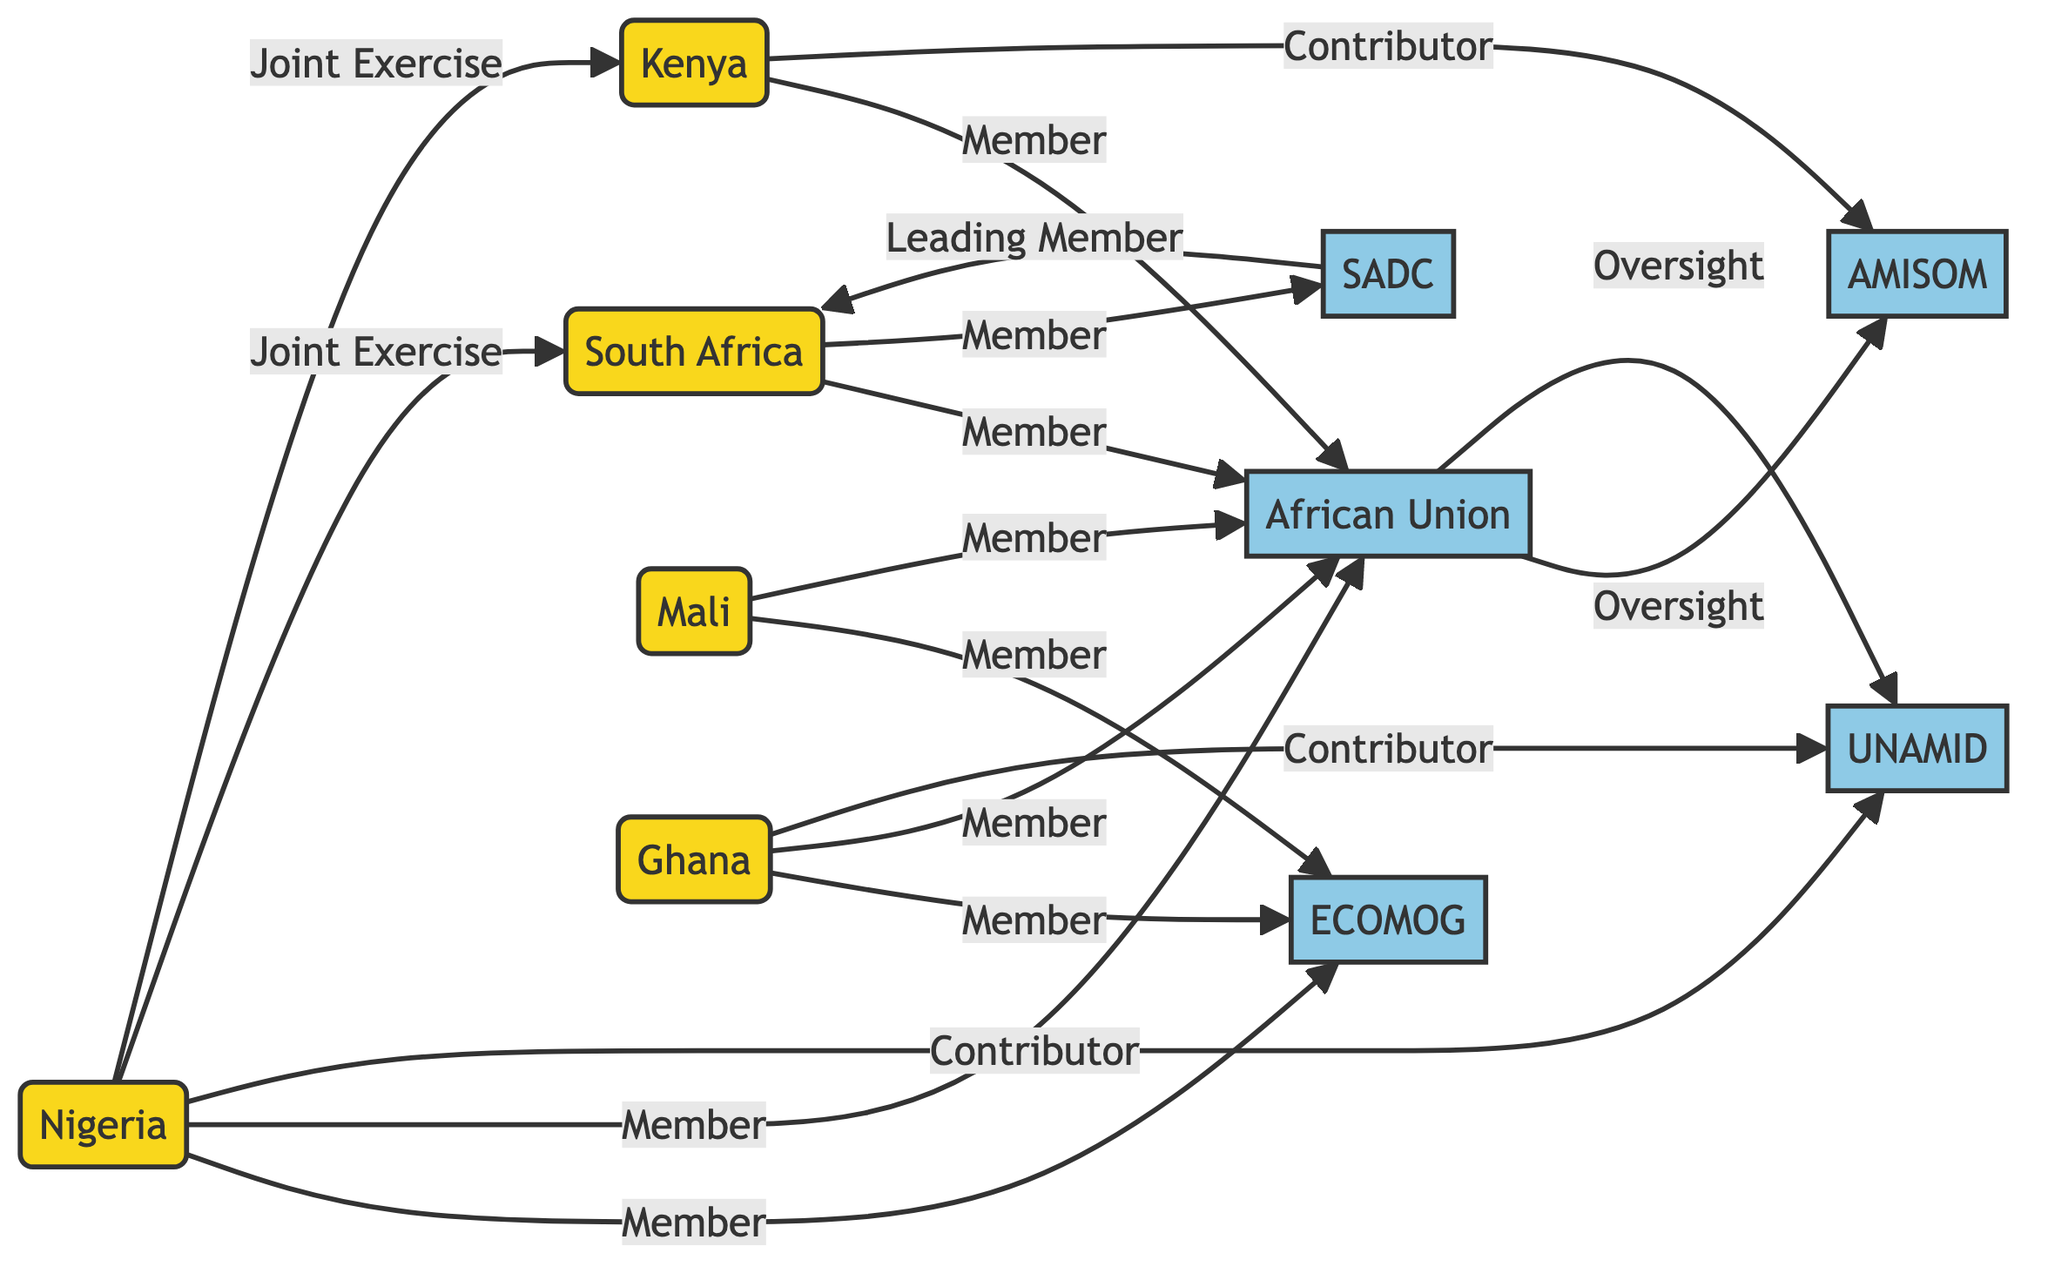What is the total number of nodes in the diagram? The diagram contains nodes for countries and alliances. Counting all the country nodes (Nigeria, South Africa, Kenya, Mali, Ghana) gives 5, and counting all the alliance nodes (ECOMOG, AU, UNAMID, SADC, AMISOM) gives 5 as well. So, 5 + 5 = 10 nodes total.
Answer: 10 Which alliance is Nigeria a member of? The edges from Nigeria point to ECOMOG and AU, indicating that Nigeria is a member of both these alliances. The relationships are explicitly marked as "Member."
Answer: ECOMOG, AU How many alliances are South Africa a member of? South Africa is connected to the AU and SADC, which are both labeled with "Member" connections. Thus, South Africa is a member of 2 alliances.
Answer: 2 What type of relationship is there between Nigeria and South Africa? The relationship is labeled "Joint Exercise," which indicates a collaboration type between these two countries. This is a direct connection seen in the diagram.
Answer: Joint Exercise What country contributes to UNAMID? The diagram shows that the edge from Nigeria to UNAMID is labeled "Contributor," indicating that Nigeria contributes to this alliance.
Answer: Nigeria Which alliance oversees AMISOM? There is an edge from the AU to AMISOM that is labeled "Oversight," indicating that the African Union has oversight over AMISOM. This relationship is verbally stated in the diagram.
Answer: AU Which country is a leading member of SADC? The diagram shows a direct edge from SADC to South Africa labeled "Leading Member," indicating that South Africa holds this position within SADC.
Answer: South Africa How many edges connect Kenya to alliances? Counting the edges for Kenya, there is one labeled "Member" to AU and another labeled "Contributor" to AMISOM. Thus, there are 2 edges connected to alliances associated with Kenya.
Answer: 2 What is the connection between Mali and ECOMOG? The edge from Mali to ECOMOG is labeled "Member," indicating that Mali is a member of this alliance. This is a straightforward relationship defined in the diagram.
Answer: Member 